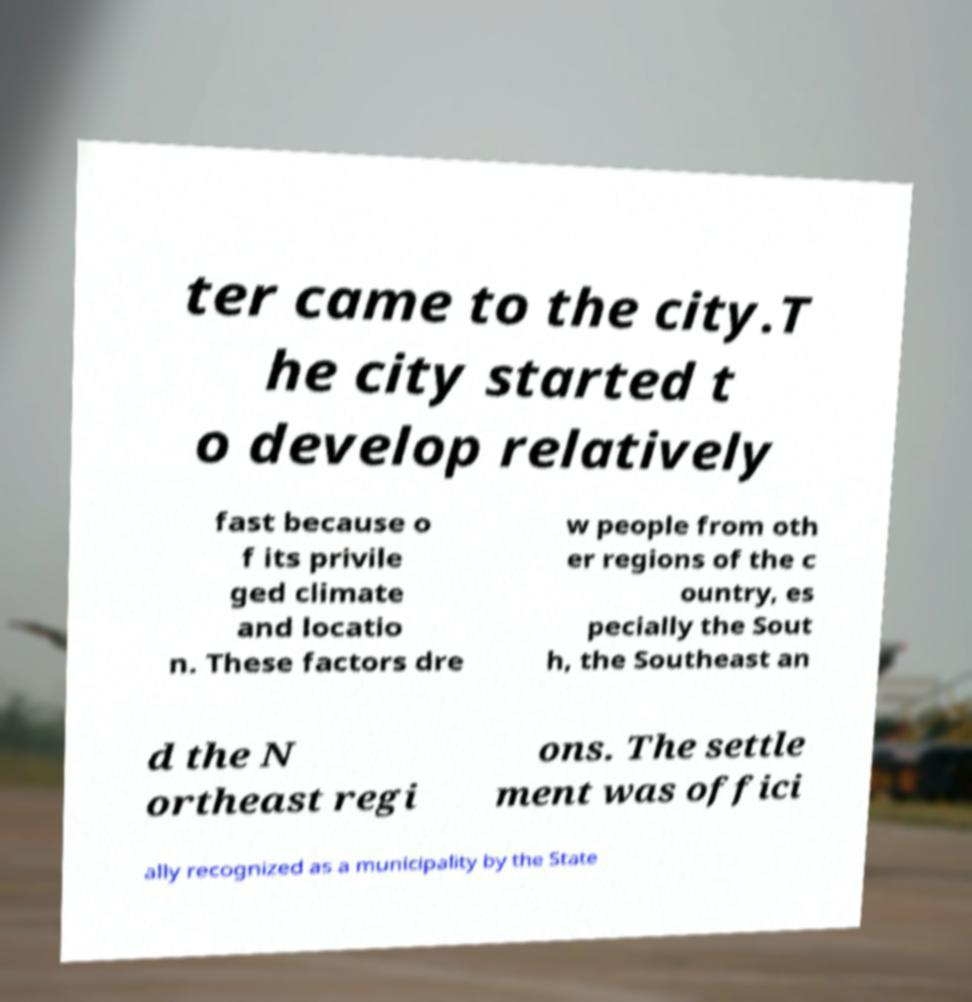For documentation purposes, I need the text within this image transcribed. Could you provide that? ter came to the city.T he city started t o develop relatively fast because o f its privile ged climate and locatio n. These factors dre w people from oth er regions of the c ountry, es pecially the Sout h, the Southeast an d the N ortheast regi ons. The settle ment was offici ally recognized as a municipality by the State 